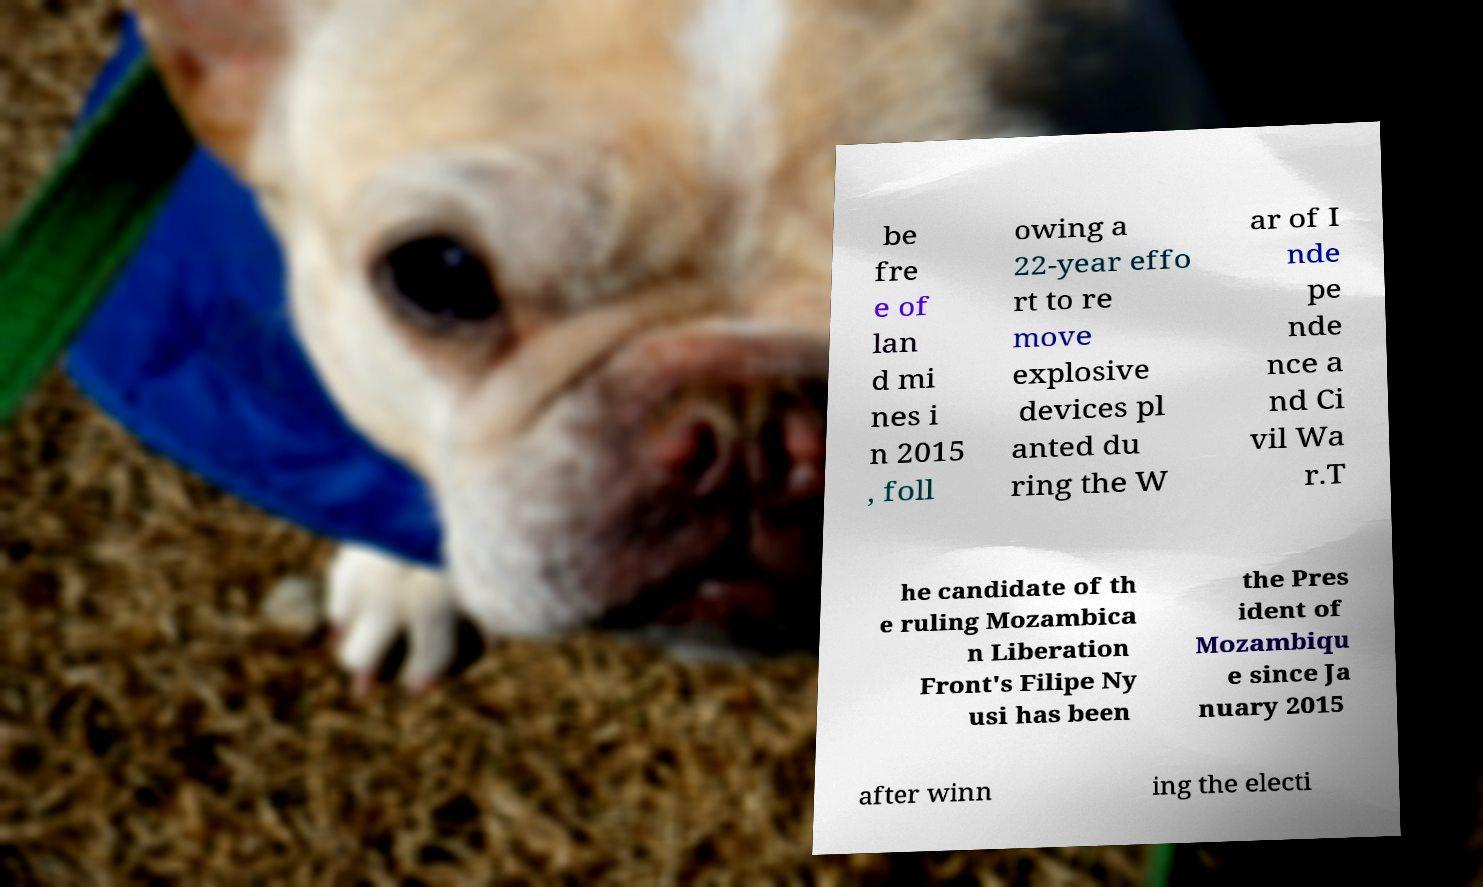Can you read and provide the text displayed in the image?This photo seems to have some interesting text. Can you extract and type it out for me? be fre e of lan d mi nes i n 2015 , foll owing a 22-year effo rt to re move explosive devices pl anted du ring the W ar of I nde pe nde nce a nd Ci vil Wa r.T he candidate of th e ruling Mozambica n Liberation Front's Filipe Ny usi has been the Pres ident of Mozambiqu e since Ja nuary 2015 after winn ing the electi 